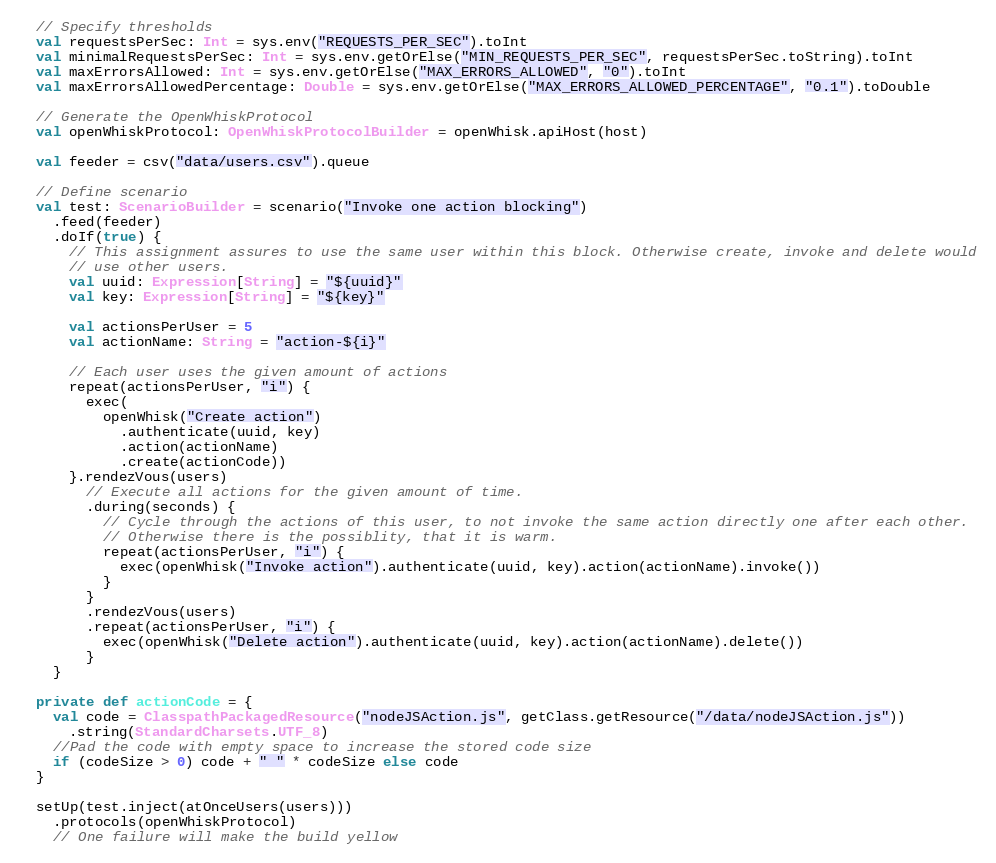Convert code to text. <code><loc_0><loc_0><loc_500><loc_500><_Scala_>
  // Specify thresholds
  val requestsPerSec: Int = sys.env("REQUESTS_PER_SEC").toInt
  val minimalRequestsPerSec: Int = sys.env.getOrElse("MIN_REQUESTS_PER_SEC", requestsPerSec.toString).toInt
  val maxErrorsAllowed: Int = sys.env.getOrElse("MAX_ERRORS_ALLOWED", "0").toInt
  val maxErrorsAllowedPercentage: Double = sys.env.getOrElse("MAX_ERRORS_ALLOWED_PERCENTAGE", "0.1").toDouble

  // Generate the OpenWhiskProtocol
  val openWhiskProtocol: OpenWhiskProtocolBuilder = openWhisk.apiHost(host)

  val feeder = csv("data/users.csv").queue

  // Define scenario
  val test: ScenarioBuilder = scenario("Invoke one action blocking")
    .feed(feeder)
    .doIf(true) {
      // This assignment assures to use the same user within this block. Otherwise create, invoke and delete would
      // use other users.
      val uuid: Expression[String] = "${uuid}"
      val key: Expression[String] = "${key}"

      val actionsPerUser = 5
      val actionName: String = "action-${i}"

      // Each user uses the given amount of actions
      repeat(actionsPerUser, "i") {
        exec(
          openWhisk("Create action")
            .authenticate(uuid, key)
            .action(actionName)
            .create(actionCode))
      }.rendezVous(users)
        // Execute all actions for the given amount of time.
        .during(seconds) {
          // Cycle through the actions of this user, to not invoke the same action directly one after each other.
          // Otherwise there is the possiblity, that it is warm.
          repeat(actionsPerUser, "i") {
            exec(openWhisk("Invoke action").authenticate(uuid, key).action(actionName).invoke())
          }
        }
        .rendezVous(users)
        .repeat(actionsPerUser, "i") {
          exec(openWhisk("Delete action").authenticate(uuid, key).action(actionName).delete())
        }
    }

  private def actionCode = {
    val code = ClasspathPackagedResource("nodeJSAction.js", getClass.getResource("/data/nodeJSAction.js"))
      .string(StandardCharsets.UTF_8)
    //Pad the code with empty space to increase the stored code size
    if (codeSize > 0) code + " " * codeSize else code
  }

  setUp(test.inject(atOnceUsers(users)))
    .protocols(openWhiskProtocol)
    // One failure will make the build yellow</code> 